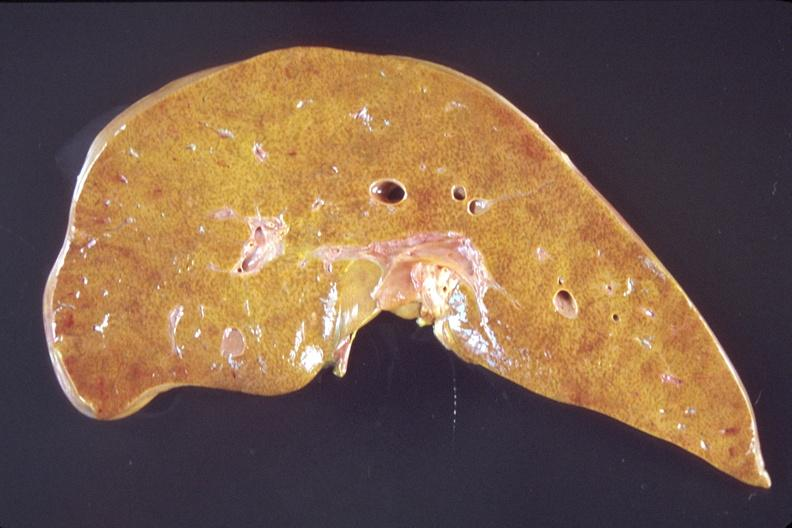does this image show liver, early chronic passive congestion?
Answer the question using a single word or phrase. Yes 